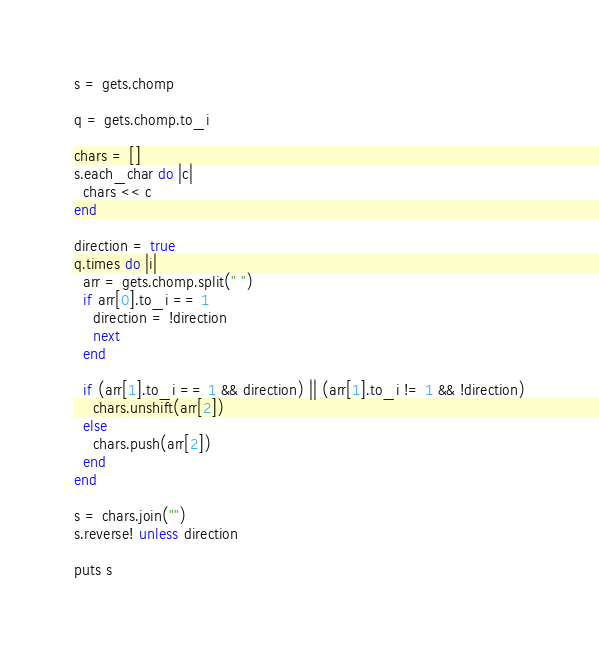<code> <loc_0><loc_0><loc_500><loc_500><_Ruby_>s = gets.chomp

q = gets.chomp.to_i

chars = []
s.each_char do |c|
  chars << c
end

direction = true
q.times do |i|
  arr = gets.chomp.split(" ")
  if arr[0].to_i == 1
    direction = !direction
    next
  end

  if (arr[1].to_i == 1 && direction) || (arr[1].to_i != 1 && !direction)
    chars.unshift(arr[2])
  else
    chars.push(arr[2])
  end
end

s = chars.join("")
s.reverse! unless direction

puts s</code> 